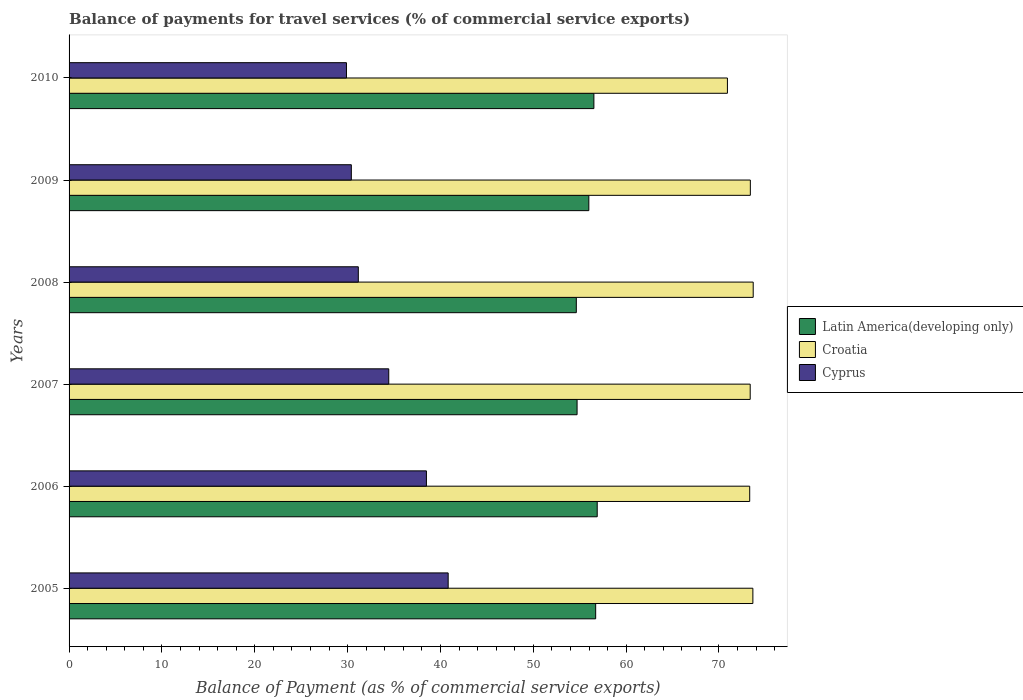How many groups of bars are there?
Ensure brevity in your answer.  6. How many bars are there on the 3rd tick from the bottom?
Give a very brief answer. 3. In how many cases, is the number of bars for a given year not equal to the number of legend labels?
Offer a terse response. 0. What is the balance of payments for travel services in Croatia in 2008?
Make the answer very short. 73.69. Across all years, what is the maximum balance of payments for travel services in Cyprus?
Your response must be concise. 40.83. Across all years, what is the minimum balance of payments for travel services in Cyprus?
Ensure brevity in your answer.  29.88. In which year was the balance of payments for travel services in Croatia minimum?
Your response must be concise. 2010. What is the total balance of payments for travel services in Croatia in the graph?
Provide a short and direct response. 438.3. What is the difference between the balance of payments for travel services in Latin America(developing only) in 2007 and that in 2009?
Your response must be concise. -1.26. What is the difference between the balance of payments for travel services in Cyprus in 2005 and the balance of payments for travel services in Croatia in 2009?
Provide a short and direct response. -32.55. What is the average balance of payments for travel services in Cyprus per year?
Give a very brief answer. 34.2. In the year 2005, what is the difference between the balance of payments for travel services in Latin America(developing only) and balance of payments for travel services in Cyprus?
Your response must be concise. 15.89. What is the ratio of the balance of payments for travel services in Cyprus in 2007 to that in 2009?
Provide a succinct answer. 1.13. What is the difference between the highest and the second highest balance of payments for travel services in Cyprus?
Your response must be concise. 2.34. What is the difference between the highest and the lowest balance of payments for travel services in Croatia?
Give a very brief answer. 2.78. In how many years, is the balance of payments for travel services in Croatia greater than the average balance of payments for travel services in Croatia taken over all years?
Your answer should be very brief. 5. Is the sum of the balance of payments for travel services in Croatia in 2007 and 2009 greater than the maximum balance of payments for travel services in Cyprus across all years?
Offer a terse response. Yes. What does the 2nd bar from the top in 2006 represents?
Your answer should be compact. Croatia. What does the 1st bar from the bottom in 2005 represents?
Give a very brief answer. Latin America(developing only). Is it the case that in every year, the sum of the balance of payments for travel services in Latin America(developing only) and balance of payments for travel services in Croatia is greater than the balance of payments for travel services in Cyprus?
Your response must be concise. Yes. Are all the bars in the graph horizontal?
Your answer should be very brief. Yes. What is the difference between two consecutive major ticks on the X-axis?
Your answer should be very brief. 10. Does the graph contain any zero values?
Keep it short and to the point. No. Does the graph contain grids?
Provide a succinct answer. No. What is the title of the graph?
Make the answer very short. Balance of payments for travel services (% of commercial service exports). What is the label or title of the X-axis?
Your answer should be very brief. Balance of Payment (as % of commercial service exports). What is the label or title of the Y-axis?
Ensure brevity in your answer.  Years. What is the Balance of Payment (as % of commercial service exports) of Latin America(developing only) in 2005?
Provide a short and direct response. 56.72. What is the Balance of Payment (as % of commercial service exports) of Croatia in 2005?
Your answer should be compact. 73.65. What is the Balance of Payment (as % of commercial service exports) in Cyprus in 2005?
Ensure brevity in your answer.  40.83. What is the Balance of Payment (as % of commercial service exports) of Latin America(developing only) in 2006?
Provide a succinct answer. 56.89. What is the Balance of Payment (as % of commercial service exports) in Croatia in 2006?
Keep it short and to the point. 73.31. What is the Balance of Payment (as % of commercial service exports) in Cyprus in 2006?
Offer a very short reply. 38.49. What is the Balance of Payment (as % of commercial service exports) in Latin America(developing only) in 2007?
Keep it short and to the point. 54.72. What is the Balance of Payment (as % of commercial service exports) in Croatia in 2007?
Offer a very short reply. 73.36. What is the Balance of Payment (as % of commercial service exports) of Cyprus in 2007?
Ensure brevity in your answer.  34.43. What is the Balance of Payment (as % of commercial service exports) of Latin America(developing only) in 2008?
Give a very brief answer. 54.63. What is the Balance of Payment (as % of commercial service exports) in Croatia in 2008?
Keep it short and to the point. 73.69. What is the Balance of Payment (as % of commercial service exports) in Cyprus in 2008?
Give a very brief answer. 31.15. What is the Balance of Payment (as % of commercial service exports) in Latin America(developing only) in 2009?
Keep it short and to the point. 55.98. What is the Balance of Payment (as % of commercial service exports) of Croatia in 2009?
Offer a very short reply. 73.38. What is the Balance of Payment (as % of commercial service exports) of Cyprus in 2009?
Make the answer very short. 30.4. What is the Balance of Payment (as % of commercial service exports) of Latin America(developing only) in 2010?
Provide a succinct answer. 56.53. What is the Balance of Payment (as % of commercial service exports) of Croatia in 2010?
Provide a short and direct response. 70.91. What is the Balance of Payment (as % of commercial service exports) in Cyprus in 2010?
Provide a short and direct response. 29.88. Across all years, what is the maximum Balance of Payment (as % of commercial service exports) of Latin America(developing only)?
Your answer should be compact. 56.89. Across all years, what is the maximum Balance of Payment (as % of commercial service exports) in Croatia?
Keep it short and to the point. 73.69. Across all years, what is the maximum Balance of Payment (as % of commercial service exports) in Cyprus?
Offer a terse response. 40.83. Across all years, what is the minimum Balance of Payment (as % of commercial service exports) in Latin America(developing only)?
Offer a very short reply. 54.63. Across all years, what is the minimum Balance of Payment (as % of commercial service exports) in Croatia?
Give a very brief answer. 70.91. Across all years, what is the minimum Balance of Payment (as % of commercial service exports) in Cyprus?
Provide a succinct answer. 29.88. What is the total Balance of Payment (as % of commercial service exports) of Latin America(developing only) in the graph?
Make the answer very short. 335.46. What is the total Balance of Payment (as % of commercial service exports) in Croatia in the graph?
Make the answer very short. 438.3. What is the total Balance of Payment (as % of commercial service exports) of Cyprus in the graph?
Your answer should be very brief. 205.18. What is the difference between the Balance of Payment (as % of commercial service exports) in Latin America(developing only) in 2005 and that in 2006?
Your answer should be very brief. -0.17. What is the difference between the Balance of Payment (as % of commercial service exports) of Croatia in 2005 and that in 2006?
Provide a succinct answer. 0.34. What is the difference between the Balance of Payment (as % of commercial service exports) in Cyprus in 2005 and that in 2006?
Keep it short and to the point. 2.34. What is the difference between the Balance of Payment (as % of commercial service exports) in Latin America(developing only) in 2005 and that in 2007?
Offer a very short reply. 2. What is the difference between the Balance of Payment (as % of commercial service exports) of Croatia in 2005 and that in 2007?
Give a very brief answer. 0.29. What is the difference between the Balance of Payment (as % of commercial service exports) of Cyprus in 2005 and that in 2007?
Keep it short and to the point. 6.4. What is the difference between the Balance of Payment (as % of commercial service exports) in Latin America(developing only) in 2005 and that in 2008?
Keep it short and to the point. 2.08. What is the difference between the Balance of Payment (as % of commercial service exports) in Croatia in 2005 and that in 2008?
Your response must be concise. -0.04. What is the difference between the Balance of Payment (as % of commercial service exports) of Cyprus in 2005 and that in 2008?
Provide a succinct answer. 9.68. What is the difference between the Balance of Payment (as % of commercial service exports) of Latin America(developing only) in 2005 and that in 2009?
Your answer should be compact. 0.74. What is the difference between the Balance of Payment (as % of commercial service exports) in Croatia in 2005 and that in 2009?
Your answer should be compact. 0.27. What is the difference between the Balance of Payment (as % of commercial service exports) of Cyprus in 2005 and that in 2009?
Provide a short and direct response. 10.43. What is the difference between the Balance of Payment (as % of commercial service exports) in Latin America(developing only) in 2005 and that in 2010?
Your answer should be compact. 0.19. What is the difference between the Balance of Payment (as % of commercial service exports) of Croatia in 2005 and that in 2010?
Offer a very short reply. 2.74. What is the difference between the Balance of Payment (as % of commercial service exports) in Cyprus in 2005 and that in 2010?
Provide a short and direct response. 10.96. What is the difference between the Balance of Payment (as % of commercial service exports) of Latin America(developing only) in 2006 and that in 2007?
Your response must be concise. 2.17. What is the difference between the Balance of Payment (as % of commercial service exports) in Croatia in 2006 and that in 2007?
Your answer should be very brief. -0.05. What is the difference between the Balance of Payment (as % of commercial service exports) in Cyprus in 2006 and that in 2007?
Your answer should be very brief. 4.06. What is the difference between the Balance of Payment (as % of commercial service exports) of Latin America(developing only) in 2006 and that in 2008?
Give a very brief answer. 2.25. What is the difference between the Balance of Payment (as % of commercial service exports) of Croatia in 2006 and that in 2008?
Give a very brief answer. -0.38. What is the difference between the Balance of Payment (as % of commercial service exports) of Cyprus in 2006 and that in 2008?
Offer a terse response. 7.34. What is the difference between the Balance of Payment (as % of commercial service exports) in Latin America(developing only) in 2006 and that in 2009?
Offer a very short reply. 0.9. What is the difference between the Balance of Payment (as % of commercial service exports) of Croatia in 2006 and that in 2009?
Keep it short and to the point. -0.07. What is the difference between the Balance of Payment (as % of commercial service exports) in Cyprus in 2006 and that in 2009?
Offer a very short reply. 8.09. What is the difference between the Balance of Payment (as % of commercial service exports) in Latin America(developing only) in 2006 and that in 2010?
Your response must be concise. 0.36. What is the difference between the Balance of Payment (as % of commercial service exports) in Croatia in 2006 and that in 2010?
Offer a terse response. 2.4. What is the difference between the Balance of Payment (as % of commercial service exports) in Cyprus in 2006 and that in 2010?
Provide a succinct answer. 8.61. What is the difference between the Balance of Payment (as % of commercial service exports) of Latin America(developing only) in 2007 and that in 2008?
Your answer should be compact. 0.08. What is the difference between the Balance of Payment (as % of commercial service exports) of Croatia in 2007 and that in 2008?
Give a very brief answer. -0.32. What is the difference between the Balance of Payment (as % of commercial service exports) in Cyprus in 2007 and that in 2008?
Your response must be concise. 3.28. What is the difference between the Balance of Payment (as % of commercial service exports) in Latin America(developing only) in 2007 and that in 2009?
Make the answer very short. -1.26. What is the difference between the Balance of Payment (as % of commercial service exports) in Croatia in 2007 and that in 2009?
Offer a terse response. -0.02. What is the difference between the Balance of Payment (as % of commercial service exports) of Cyprus in 2007 and that in 2009?
Give a very brief answer. 4.03. What is the difference between the Balance of Payment (as % of commercial service exports) in Latin America(developing only) in 2007 and that in 2010?
Provide a short and direct response. -1.81. What is the difference between the Balance of Payment (as % of commercial service exports) of Croatia in 2007 and that in 2010?
Ensure brevity in your answer.  2.45. What is the difference between the Balance of Payment (as % of commercial service exports) in Cyprus in 2007 and that in 2010?
Keep it short and to the point. 4.55. What is the difference between the Balance of Payment (as % of commercial service exports) in Latin America(developing only) in 2008 and that in 2009?
Give a very brief answer. -1.35. What is the difference between the Balance of Payment (as % of commercial service exports) of Croatia in 2008 and that in 2009?
Provide a succinct answer. 0.31. What is the difference between the Balance of Payment (as % of commercial service exports) of Cyprus in 2008 and that in 2009?
Ensure brevity in your answer.  0.75. What is the difference between the Balance of Payment (as % of commercial service exports) in Latin America(developing only) in 2008 and that in 2010?
Give a very brief answer. -1.89. What is the difference between the Balance of Payment (as % of commercial service exports) of Croatia in 2008 and that in 2010?
Give a very brief answer. 2.78. What is the difference between the Balance of Payment (as % of commercial service exports) in Cyprus in 2008 and that in 2010?
Ensure brevity in your answer.  1.28. What is the difference between the Balance of Payment (as % of commercial service exports) of Latin America(developing only) in 2009 and that in 2010?
Give a very brief answer. -0.55. What is the difference between the Balance of Payment (as % of commercial service exports) of Croatia in 2009 and that in 2010?
Offer a very short reply. 2.47. What is the difference between the Balance of Payment (as % of commercial service exports) of Cyprus in 2009 and that in 2010?
Your answer should be very brief. 0.52. What is the difference between the Balance of Payment (as % of commercial service exports) of Latin America(developing only) in 2005 and the Balance of Payment (as % of commercial service exports) of Croatia in 2006?
Keep it short and to the point. -16.59. What is the difference between the Balance of Payment (as % of commercial service exports) of Latin America(developing only) in 2005 and the Balance of Payment (as % of commercial service exports) of Cyprus in 2006?
Ensure brevity in your answer.  18.23. What is the difference between the Balance of Payment (as % of commercial service exports) of Croatia in 2005 and the Balance of Payment (as % of commercial service exports) of Cyprus in 2006?
Your response must be concise. 35.16. What is the difference between the Balance of Payment (as % of commercial service exports) in Latin America(developing only) in 2005 and the Balance of Payment (as % of commercial service exports) in Croatia in 2007?
Your response must be concise. -16.64. What is the difference between the Balance of Payment (as % of commercial service exports) of Latin America(developing only) in 2005 and the Balance of Payment (as % of commercial service exports) of Cyprus in 2007?
Ensure brevity in your answer.  22.29. What is the difference between the Balance of Payment (as % of commercial service exports) in Croatia in 2005 and the Balance of Payment (as % of commercial service exports) in Cyprus in 2007?
Give a very brief answer. 39.22. What is the difference between the Balance of Payment (as % of commercial service exports) in Latin America(developing only) in 2005 and the Balance of Payment (as % of commercial service exports) in Croatia in 2008?
Your answer should be compact. -16.97. What is the difference between the Balance of Payment (as % of commercial service exports) of Latin America(developing only) in 2005 and the Balance of Payment (as % of commercial service exports) of Cyprus in 2008?
Your answer should be compact. 25.57. What is the difference between the Balance of Payment (as % of commercial service exports) of Croatia in 2005 and the Balance of Payment (as % of commercial service exports) of Cyprus in 2008?
Offer a very short reply. 42.5. What is the difference between the Balance of Payment (as % of commercial service exports) in Latin America(developing only) in 2005 and the Balance of Payment (as % of commercial service exports) in Croatia in 2009?
Keep it short and to the point. -16.66. What is the difference between the Balance of Payment (as % of commercial service exports) of Latin America(developing only) in 2005 and the Balance of Payment (as % of commercial service exports) of Cyprus in 2009?
Your response must be concise. 26.32. What is the difference between the Balance of Payment (as % of commercial service exports) in Croatia in 2005 and the Balance of Payment (as % of commercial service exports) in Cyprus in 2009?
Offer a terse response. 43.25. What is the difference between the Balance of Payment (as % of commercial service exports) in Latin America(developing only) in 2005 and the Balance of Payment (as % of commercial service exports) in Croatia in 2010?
Make the answer very short. -14.19. What is the difference between the Balance of Payment (as % of commercial service exports) in Latin America(developing only) in 2005 and the Balance of Payment (as % of commercial service exports) in Cyprus in 2010?
Offer a terse response. 26.84. What is the difference between the Balance of Payment (as % of commercial service exports) of Croatia in 2005 and the Balance of Payment (as % of commercial service exports) of Cyprus in 2010?
Your answer should be very brief. 43.77. What is the difference between the Balance of Payment (as % of commercial service exports) of Latin America(developing only) in 2006 and the Balance of Payment (as % of commercial service exports) of Croatia in 2007?
Offer a very short reply. -16.48. What is the difference between the Balance of Payment (as % of commercial service exports) of Latin America(developing only) in 2006 and the Balance of Payment (as % of commercial service exports) of Cyprus in 2007?
Your response must be concise. 22.45. What is the difference between the Balance of Payment (as % of commercial service exports) of Croatia in 2006 and the Balance of Payment (as % of commercial service exports) of Cyprus in 2007?
Give a very brief answer. 38.88. What is the difference between the Balance of Payment (as % of commercial service exports) of Latin America(developing only) in 2006 and the Balance of Payment (as % of commercial service exports) of Croatia in 2008?
Your answer should be very brief. -16.8. What is the difference between the Balance of Payment (as % of commercial service exports) of Latin America(developing only) in 2006 and the Balance of Payment (as % of commercial service exports) of Cyprus in 2008?
Give a very brief answer. 25.73. What is the difference between the Balance of Payment (as % of commercial service exports) of Croatia in 2006 and the Balance of Payment (as % of commercial service exports) of Cyprus in 2008?
Offer a very short reply. 42.16. What is the difference between the Balance of Payment (as % of commercial service exports) in Latin America(developing only) in 2006 and the Balance of Payment (as % of commercial service exports) in Croatia in 2009?
Provide a short and direct response. -16.49. What is the difference between the Balance of Payment (as % of commercial service exports) of Latin America(developing only) in 2006 and the Balance of Payment (as % of commercial service exports) of Cyprus in 2009?
Provide a short and direct response. 26.48. What is the difference between the Balance of Payment (as % of commercial service exports) of Croatia in 2006 and the Balance of Payment (as % of commercial service exports) of Cyprus in 2009?
Provide a succinct answer. 42.91. What is the difference between the Balance of Payment (as % of commercial service exports) of Latin America(developing only) in 2006 and the Balance of Payment (as % of commercial service exports) of Croatia in 2010?
Offer a terse response. -14.02. What is the difference between the Balance of Payment (as % of commercial service exports) of Latin America(developing only) in 2006 and the Balance of Payment (as % of commercial service exports) of Cyprus in 2010?
Offer a very short reply. 27.01. What is the difference between the Balance of Payment (as % of commercial service exports) of Croatia in 2006 and the Balance of Payment (as % of commercial service exports) of Cyprus in 2010?
Your response must be concise. 43.43. What is the difference between the Balance of Payment (as % of commercial service exports) of Latin America(developing only) in 2007 and the Balance of Payment (as % of commercial service exports) of Croatia in 2008?
Provide a short and direct response. -18.97. What is the difference between the Balance of Payment (as % of commercial service exports) of Latin America(developing only) in 2007 and the Balance of Payment (as % of commercial service exports) of Cyprus in 2008?
Give a very brief answer. 23.56. What is the difference between the Balance of Payment (as % of commercial service exports) of Croatia in 2007 and the Balance of Payment (as % of commercial service exports) of Cyprus in 2008?
Offer a terse response. 42.21. What is the difference between the Balance of Payment (as % of commercial service exports) of Latin America(developing only) in 2007 and the Balance of Payment (as % of commercial service exports) of Croatia in 2009?
Provide a short and direct response. -18.66. What is the difference between the Balance of Payment (as % of commercial service exports) of Latin America(developing only) in 2007 and the Balance of Payment (as % of commercial service exports) of Cyprus in 2009?
Provide a succinct answer. 24.31. What is the difference between the Balance of Payment (as % of commercial service exports) in Croatia in 2007 and the Balance of Payment (as % of commercial service exports) in Cyprus in 2009?
Ensure brevity in your answer.  42.96. What is the difference between the Balance of Payment (as % of commercial service exports) of Latin America(developing only) in 2007 and the Balance of Payment (as % of commercial service exports) of Croatia in 2010?
Provide a short and direct response. -16.19. What is the difference between the Balance of Payment (as % of commercial service exports) of Latin America(developing only) in 2007 and the Balance of Payment (as % of commercial service exports) of Cyprus in 2010?
Offer a terse response. 24.84. What is the difference between the Balance of Payment (as % of commercial service exports) of Croatia in 2007 and the Balance of Payment (as % of commercial service exports) of Cyprus in 2010?
Give a very brief answer. 43.49. What is the difference between the Balance of Payment (as % of commercial service exports) of Latin America(developing only) in 2008 and the Balance of Payment (as % of commercial service exports) of Croatia in 2009?
Your response must be concise. -18.74. What is the difference between the Balance of Payment (as % of commercial service exports) of Latin America(developing only) in 2008 and the Balance of Payment (as % of commercial service exports) of Cyprus in 2009?
Your response must be concise. 24.23. What is the difference between the Balance of Payment (as % of commercial service exports) of Croatia in 2008 and the Balance of Payment (as % of commercial service exports) of Cyprus in 2009?
Keep it short and to the point. 43.28. What is the difference between the Balance of Payment (as % of commercial service exports) of Latin America(developing only) in 2008 and the Balance of Payment (as % of commercial service exports) of Croatia in 2010?
Keep it short and to the point. -16.28. What is the difference between the Balance of Payment (as % of commercial service exports) in Latin America(developing only) in 2008 and the Balance of Payment (as % of commercial service exports) in Cyprus in 2010?
Offer a terse response. 24.76. What is the difference between the Balance of Payment (as % of commercial service exports) in Croatia in 2008 and the Balance of Payment (as % of commercial service exports) in Cyprus in 2010?
Give a very brief answer. 43.81. What is the difference between the Balance of Payment (as % of commercial service exports) in Latin America(developing only) in 2009 and the Balance of Payment (as % of commercial service exports) in Croatia in 2010?
Your answer should be very brief. -14.93. What is the difference between the Balance of Payment (as % of commercial service exports) of Latin America(developing only) in 2009 and the Balance of Payment (as % of commercial service exports) of Cyprus in 2010?
Provide a succinct answer. 26.1. What is the difference between the Balance of Payment (as % of commercial service exports) of Croatia in 2009 and the Balance of Payment (as % of commercial service exports) of Cyprus in 2010?
Give a very brief answer. 43.5. What is the average Balance of Payment (as % of commercial service exports) of Latin America(developing only) per year?
Offer a terse response. 55.91. What is the average Balance of Payment (as % of commercial service exports) of Croatia per year?
Give a very brief answer. 73.05. What is the average Balance of Payment (as % of commercial service exports) in Cyprus per year?
Your answer should be compact. 34.2. In the year 2005, what is the difference between the Balance of Payment (as % of commercial service exports) in Latin America(developing only) and Balance of Payment (as % of commercial service exports) in Croatia?
Offer a terse response. -16.93. In the year 2005, what is the difference between the Balance of Payment (as % of commercial service exports) of Latin America(developing only) and Balance of Payment (as % of commercial service exports) of Cyprus?
Offer a terse response. 15.89. In the year 2005, what is the difference between the Balance of Payment (as % of commercial service exports) of Croatia and Balance of Payment (as % of commercial service exports) of Cyprus?
Offer a terse response. 32.82. In the year 2006, what is the difference between the Balance of Payment (as % of commercial service exports) of Latin America(developing only) and Balance of Payment (as % of commercial service exports) of Croatia?
Your answer should be compact. -16.42. In the year 2006, what is the difference between the Balance of Payment (as % of commercial service exports) in Latin America(developing only) and Balance of Payment (as % of commercial service exports) in Cyprus?
Make the answer very short. 18.4. In the year 2006, what is the difference between the Balance of Payment (as % of commercial service exports) of Croatia and Balance of Payment (as % of commercial service exports) of Cyprus?
Offer a very short reply. 34.82. In the year 2007, what is the difference between the Balance of Payment (as % of commercial service exports) of Latin America(developing only) and Balance of Payment (as % of commercial service exports) of Croatia?
Provide a short and direct response. -18.65. In the year 2007, what is the difference between the Balance of Payment (as % of commercial service exports) of Latin America(developing only) and Balance of Payment (as % of commercial service exports) of Cyprus?
Offer a terse response. 20.29. In the year 2007, what is the difference between the Balance of Payment (as % of commercial service exports) in Croatia and Balance of Payment (as % of commercial service exports) in Cyprus?
Offer a terse response. 38.93. In the year 2008, what is the difference between the Balance of Payment (as % of commercial service exports) in Latin America(developing only) and Balance of Payment (as % of commercial service exports) in Croatia?
Make the answer very short. -19.05. In the year 2008, what is the difference between the Balance of Payment (as % of commercial service exports) of Latin America(developing only) and Balance of Payment (as % of commercial service exports) of Cyprus?
Offer a very short reply. 23.48. In the year 2008, what is the difference between the Balance of Payment (as % of commercial service exports) of Croatia and Balance of Payment (as % of commercial service exports) of Cyprus?
Ensure brevity in your answer.  42.53. In the year 2009, what is the difference between the Balance of Payment (as % of commercial service exports) in Latin America(developing only) and Balance of Payment (as % of commercial service exports) in Croatia?
Keep it short and to the point. -17.4. In the year 2009, what is the difference between the Balance of Payment (as % of commercial service exports) in Latin America(developing only) and Balance of Payment (as % of commercial service exports) in Cyprus?
Make the answer very short. 25.58. In the year 2009, what is the difference between the Balance of Payment (as % of commercial service exports) of Croatia and Balance of Payment (as % of commercial service exports) of Cyprus?
Your answer should be compact. 42.98. In the year 2010, what is the difference between the Balance of Payment (as % of commercial service exports) of Latin America(developing only) and Balance of Payment (as % of commercial service exports) of Croatia?
Offer a terse response. -14.38. In the year 2010, what is the difference between the Balance of Payment (as % of commercial service exports) in Latin America(developing only) and Balance of Payment (as % of commercial service exports) in Cyprus?
Ensure brevity in your answer.  26.65. In the year 2010, what is the difference between the Balance of Payment (as % of commercial service exports) in Croatia and Balance of Payment (as % of commercial service exports) in Cyprus?
Provide a succinct answer. 41.03. What is the ratio of the Balance of Payment (as % of commercial service exports) in Latin America(developing only) in 2005 to that in 2006?
Ensure brevity in your answer.  1. What is the ratio of the Balance of Payment (as % of commercial service exports) in Cyprus in 2005 to that in 2006?
Make the answer very short. 1.06. What is the ratio of the Balance of Payment (as % of commercial service exports) of Latin America(developing only) in 2005 to that in 2007?
Make the answer very short. 1.04. What is the ratio of the Balance of Payment (as % of commercial service exports) of Cyprus in 2005 to that in 2007?
Keep it short and to the point. 1.19. What is the ratio of the Balance of Payment (as % of commercial service exports) in Latin America(developing only) in 2005 to that in 2008?
Your answer should be very brief. 1.04. What is the ratio of the Balance of Payment (as % of commercial service exports) in Cyprus in 2005 to that in 2008?
Your answer should be compact. 1.31. What is the ratio of the Balance of Payment (as % of commercial service exports) in Latin America(developing only) in 2005 to that in 2009?
Ensure brevity in your answer.  1.01. What is the ratio of the Balance of Payment (as % of commercial service exports) in Croatia in 2005 to that in 2009?
Offer a very short reply. 1. What is the ratio of the Balance of Payment (as % of commercial service exports) in Cyprus in 2005 to that in 2009?
Make the answer very short. 1.34. What is the ratio of the Balance of Payment (as % of commercial service exports) in Latin America(developing only) in 2005 to that in 2010?
Keep it short and to the point. 1. What is the ratio of the Balance of Payment (as % of commercial service exports) in Croatia in 2005 to that in 2010?
Provide a succinct answer. 1.04. What is the ratio of the Balance of Payment (as % of commercial service exports) of Cyprus in 2005 to that in 2010?
Your answer should be compact. 1.37. What is the ratio of the Balance of Payment (as % of commercial service exports) of Latin America(developing only) in 2006 to that in 2007?
Your response must be concise. 1.04. What is the ratio of the Balance of Payment (as % of commercial service exports) of Croatia in 2006 to that in 2007?
Provide a short and direct response. 1. What is the ratio of the Balance of Payment (as % of commercial service exports) in Cyprus in 2006 to that in 2007?
Offer a terse response. 1.12. What is the ratio of the Balance of Payment (as % of commercial service exports) in Latin America(developing only) in 2006 to that in 2008?
Ensure brevity in your answer.  1.04. What is the ratio of the Balance of Payment (as % of commercial service exports) in Cyprus in 2006 to that in 2008?
Give a very brief answer. 1.24. What is the ratio of the Balance of Payment (as % of commercial service exports) of Latin America(developing only) in 2006 to that in 2009?
Provide a short and direct response. 1.02. What is the ratio of the Balance of Payment (as % of commercial service exports) in Cyprus in 2006 to that in 2009?
Your answer should be compact. 1.27. What is the ratio of the Balance of Payment (as % of commercial service exports) of Latin America(developing only) in 2006 to that in 2010?
Offer a terse response. 1.01. What is the ratio of the Balance of Payment (as % of commercial service exports) of Croatia in 2006 to that in 2010?
Give a very brief answer. 1.03. What is the ratio of the Balance of Payment (as % of commercial service exports) in Cyprus in 2006 to that in 2010?
Give a very brief answer. 1.29. What is the ratio of the Balance of Payment (as % of commercial service exports) of Latin America(developing only) in 2007 to that in 2008?
Give a very brief answer. 1. What is the ratio of the Balance of Payment (as % of commercial service exports) in Croatia in 2007 to that in 2008?
Your answer should be compact. 1. What is the ratio of the Balance of Payment (as % of commercial service exports) in Cyprus in 2007 to that in 2008?
Provide a succinct answer. 1.11. What is the ratio of the Balance of Payment (as % of commercial service exports) of Latin America(developing only) in 2007 to that in 2009?
Ensure brevity in your answer.  0.98. What is the ratio of the Balance of Payment (as % of commercial service exports) in Cyprus in 2007 to that in 2009?
Your response must be concise. 1.13. What is the ratio of the Balance of Payment (as % of commercial service exports) of Latin America(developing only) in 2007 to that in 2010?
Ensure brevity in your answer.  0.97. What is the ratio of the Balance of Payment (as % of commercial service exports) of Croatia in 2007 to that in 2010?
Offer a very short reply. 1.03. What is the ratio of the Balance of Payment (as % of commercial service exports) in Cyprus in 2007 to that in 2010?
Your answer should be compact. 1.15. What is the ratio of the Balance of Payment (as % of commercial service exports) in Latin America(developing only) in 2008 to that in 2009?
Your response must be concise. 0.98. What is the ratio of the Balance of Payment (as % of commercial service exports) of Croatia in 2008 to that in 2009?
Offer a very short reply. 1. What is the ratio of the Balance of Payment (as % of commercial service exports) of Cyprus in 2008 to that in 2009?
Ensure brevity in your answer.  1.02. What is the ratio of the Balance of Payment (as % of commercial service exports) of Latin America(developing only) in 2008 to that in 2010?
Your answer should be very brief. 0.97. What is the ratio of the Balance of Payment (as % of commercial service exports) in Croatia in 2008 to that in 2010?
Provide a succinct answer. 1.04. What is the ratio of the Balance of Payment (as % of commercial service exports) of Cyprus in 2008 to that in 2010?
Offer a terse response. 1.04. What is the ratio of the Balance of Payment (as % of commercial service exports) in Latin America(developing only) in 2009 to that in 2010?
Keep it short and to the point. 0.99. What is the ratio of the Balance of Payment (as % of commercial service exports) of Croatia in 2009 to that in 2010?
Offer a very short reply. 1.03. What is the ratio of the Balance of Payment (as % of commercial service exports) in Cyprus in 2009 to that in 2010?
Keep it short and to the point. 1.02. What is the difference between the highest and the second highest Balance of Payment (as % of commercial service exports) of Latin America(developing only)?
Provide a succinct answer. 0.17. What is the difference between the highest and the second highest Balance of Payment (as % of commercial service exports) of Croatia?
Make the answer very short. 0.04. What is the difference between the highest and the second highest Balance of Payment (as % of commercial service exports) in Cyprus?
Keep it short and to the point. 2.34. What is the difference between the highest and the lowest Balance of Payment (as % of commercial service exports) in Latin America(developing only)?
Your answer should be very brief. 2.25. What is the difference between the highest and the lowest Balance of Payment (as % of commercial service exports) of Croatia?
Ensure brevity in your answer.  2.78. What is the difference between the highest and the lowest Balance of Payment (as % of commercial service exports) in Cyprus?
Your response must be concise. 10.96. 